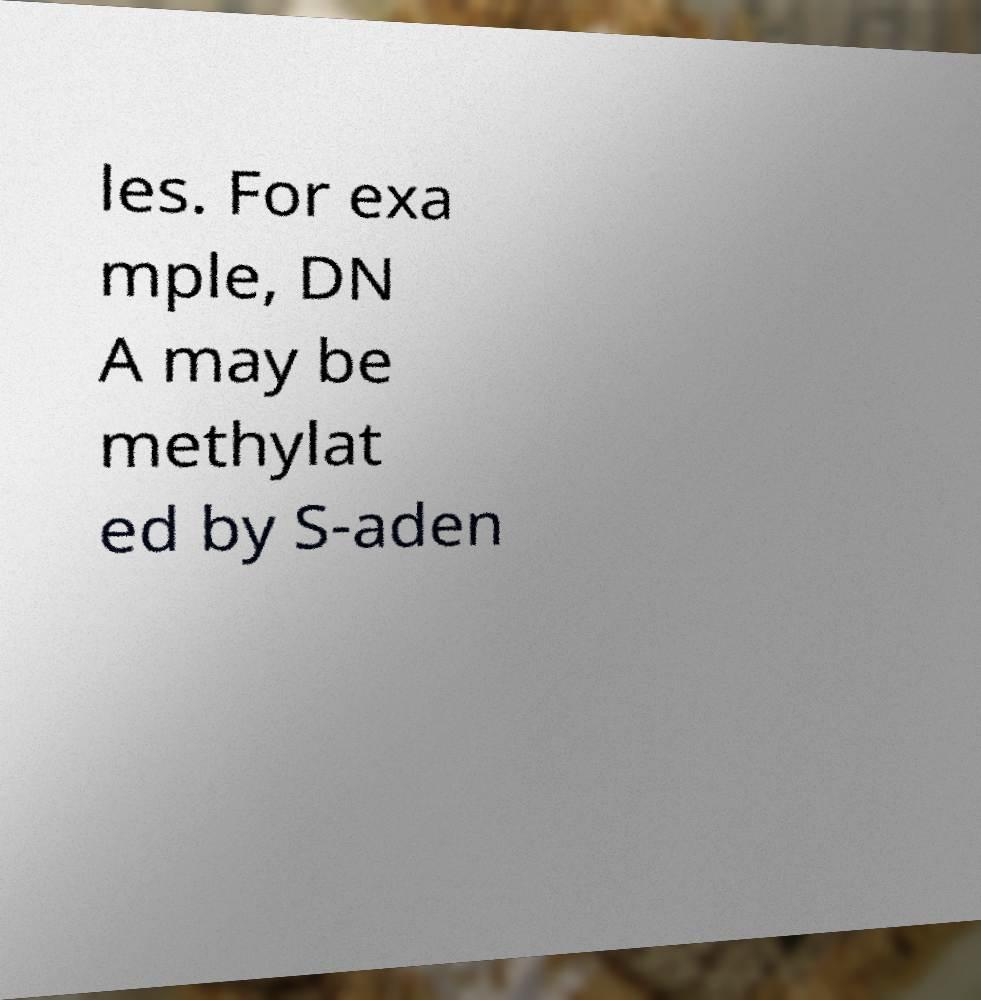I need the written content from this picture converted into text. Can you do that? les. For exa mple, DN A may be methylat ed by S-aden 